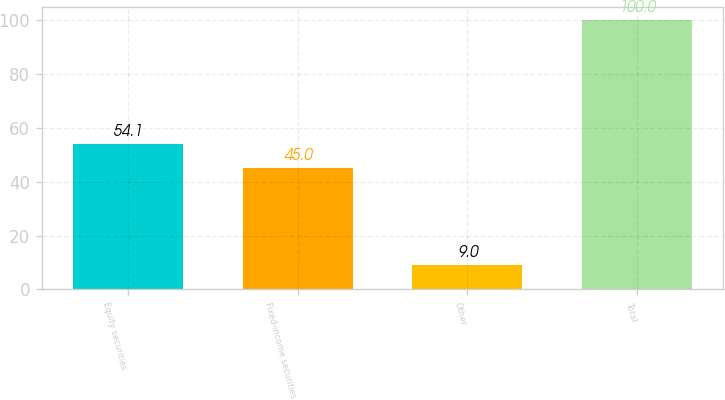Convert chart. <chart><loc_0><loc_0><loc_500><loc_500><bar_chart><fcel>Equity securities<fcel>Fixed-income securities<fcel>Other<fcel>Total<nl><fcel>54.1<fcel>45<fcel>9<fcel>100<nl></chart> 